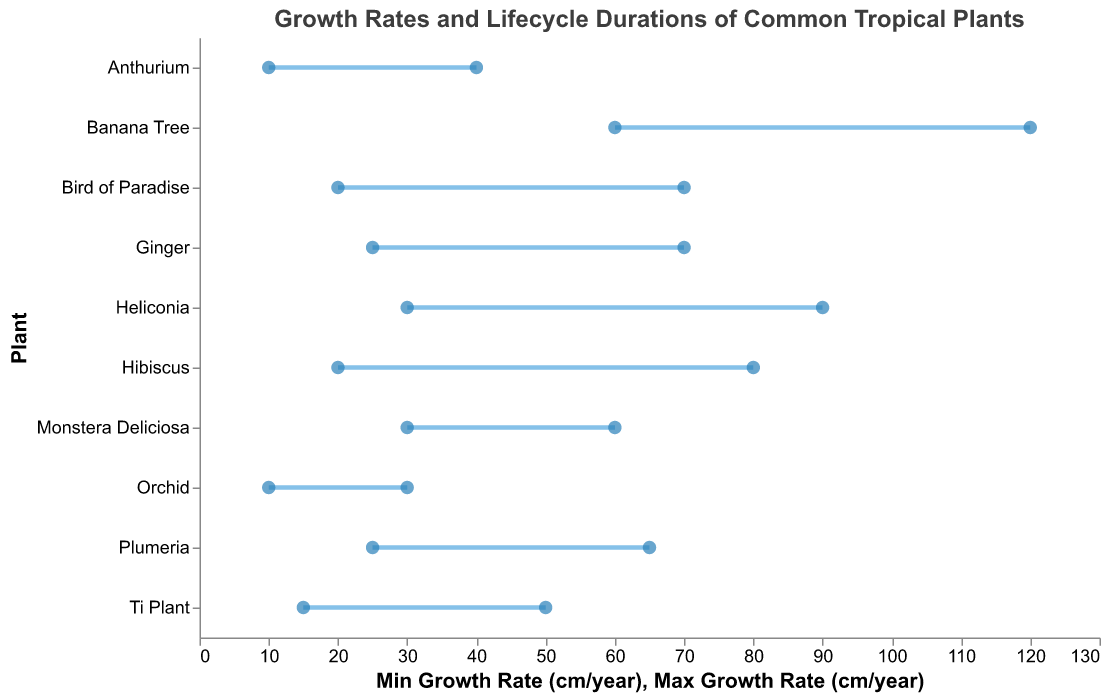What's the plant with the highest maximum growth rate? Look at the rightmost points on the figure, the Banana Tree has the highest maximum growth rate marked at 120 cm/year.
Answer: Banana Tree Which plant has the shortest minimum lifecycle? Look at the bottom of the figure for the smallest number in the Min Lifecycle (years) and find the plant associated with that value. The Orchid has the shortest minimum lifecycle marked at 1 year.
Answer: Orchid What is the growth rate range for the Hibiscus? Identify the points for Hibiscus on the growth rate axis. The minimum and maximum growth rates are marked at 20 cm/year and 80 cm/year, respectively.
Answer: 20-80 cm/year Which two plants have the same maximum lifecycle? Locate the maximum lifecycle values and find plants with the same value. Both the Banana Tree and the Plumeria have a maximum lifecycle of 8 and 7 years, respectively.
Answer: Banana Tree and Plumeria How much greater is the maximum growth rate of the Banana Tree compared to the Bird of Paradise? Subtract the maximum growth rate of the Bird of Paradise (70 cm/year) from that of the Banana Tree (120 cm/year).
Answer: 50 cm/year What plant has the narrowest growth rate range? Identify the plant whose distance between points on the growth rate axis is the smallest. The Orchid has the narrowest range of 20 cm/year (30-10).
Answer: Orchid What is the average growth rate range for the Ti Plant? Calculate the average of the minimum and maximum growth rates. For the Ti Plant, (15 + 50)/2 = 32.5.
Answer: 32.5 cm/year Which plant has the maximum lifecycle in the Philippines? Cross-reference the plant with the location "Philippines" (Ti Plant) and check its maximum lifecycle value, which is 4 years.
Answer: Ti Plant Which plants have a minimum growth rate of exactly 10 cm/year? Cross-check the plants listed with a minimum growth rate of 10 cm/year. Both Orchid and Anthurium have this value.
Answer: Orchid and Anthurium Which plant's lifecycle range overlaps most with the Monstera Deliciosa? Identify overlap by comparing the lifecycle ranges. The Monstera Deliciosa (3-7 years) overlaps most with the Plumeria (5-7 years).
Answer: Plumeria 